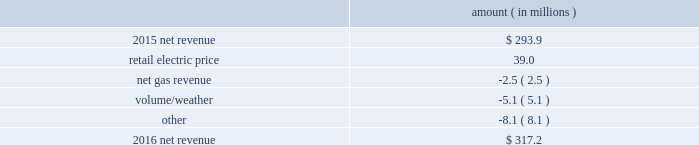Entergy new orleans , inc .
And subsidiaries management 2019s financial discussion and analysis results of operations net income 2016 compared to 2015 net income increased $ 3.9 million primarily due to higher net revenue , partially offset by higher depreciation and amortization expenses , higher interest expense , and lower other income .
2015 compared to 2014 net income increased $ 13.9 million primarily due to lower other operation and maintenance expenses and higher net revenue , partially offset by a higher effective income tax rate .
Net revenue 2016 compared to 2015 net revenue consists of operating revenues net of : 1 ) fuel , fuel-related expenses , and gas purchased for resale , 2 ) purchased power expenses , and 3 ) other regulatory charges .
Following is an analysis of the change in net revenue comparing 2016 to 2015 .
Amount ( in millions ) .
The retail electric price variance is primarily due to an increase in the purchased power and capacity acquisition cost recovery rider , as approved by the city council , effective with the first billing cycle of march 2016 , primarily related to the purchase of power block 1 of the union power station .
See note 14 to the financial statements for discussion of the union power station purchase .
The net gas revenue variance is primarily due to the effect of less favorable weather on residential and commercial sales .
The volume/weather variance is primarily due to a decrease of 112 gwh , or 2% ( 2 % ) , in billed electricity usage , partially offset by the effect of favorable weather on commercial sales and a 2% ( 2 % ) increase in the average number of electric customers. .
The net income increases in 2015 were what percent of the net income changes in 2016? 
Computations: (13.9 / 3.9)
Answer: 3.5641. Entergy new orleans , inc .
And subsidiaries management 2019s financial discussion and analysis results of operations net income 2016 compared to 2015 net income increased $ 3.9 million primarily due to higher net revenue , partially offset by higher depreciation and amortization expenses , higher interest expense , and lower other income .
2015 compared to 2014 net income increased $ 13.9 million primarily due to lower other operation and maintenance expenses and higher net revenue , partially offset by a higher effective income tax rate .
Net revenue 2016 compared to 2015 net revenue consists of operating revenues net of : 1 ) fuel , fuel-related expenses , and gas purchased for resale , 2 ) purchased power expenses , and 3 ) other regulatory charges .
Following is an analysis of the change in net revenue comparing 2016 to 2015 .
Amount ( in millions ) .
The retail electric price variance is primarily due to an increase in the purchased power and capacity acquisition cost recovery rider , as approved by the city council , effective with the first billing cycle of march 2016 , primarily related to the purchase of power block 1 of the union power station .
See note 14 to the financial statements for discussion of the union power station purchase .
The net gas revenue variance is primarily due to the effect of less favorable weather on residential and commercial sales .
The volume/weather variance is primarily due to a decrease of 112 gwh , or 2% ( 2 % ) , in billed electricity usage , partially offset by the effect of favorable weather on commercial sales and a 2% ( 2 % ) increase in the average number of electric customers. .
What was the combined impact in millions on 2016 net revenue from the net gas revenue adjustment , the volume/weather adjustment , and other adjustments? 
Computations: ((-2.5 + -5.1) + -8.1)
Answer: -15.7. 